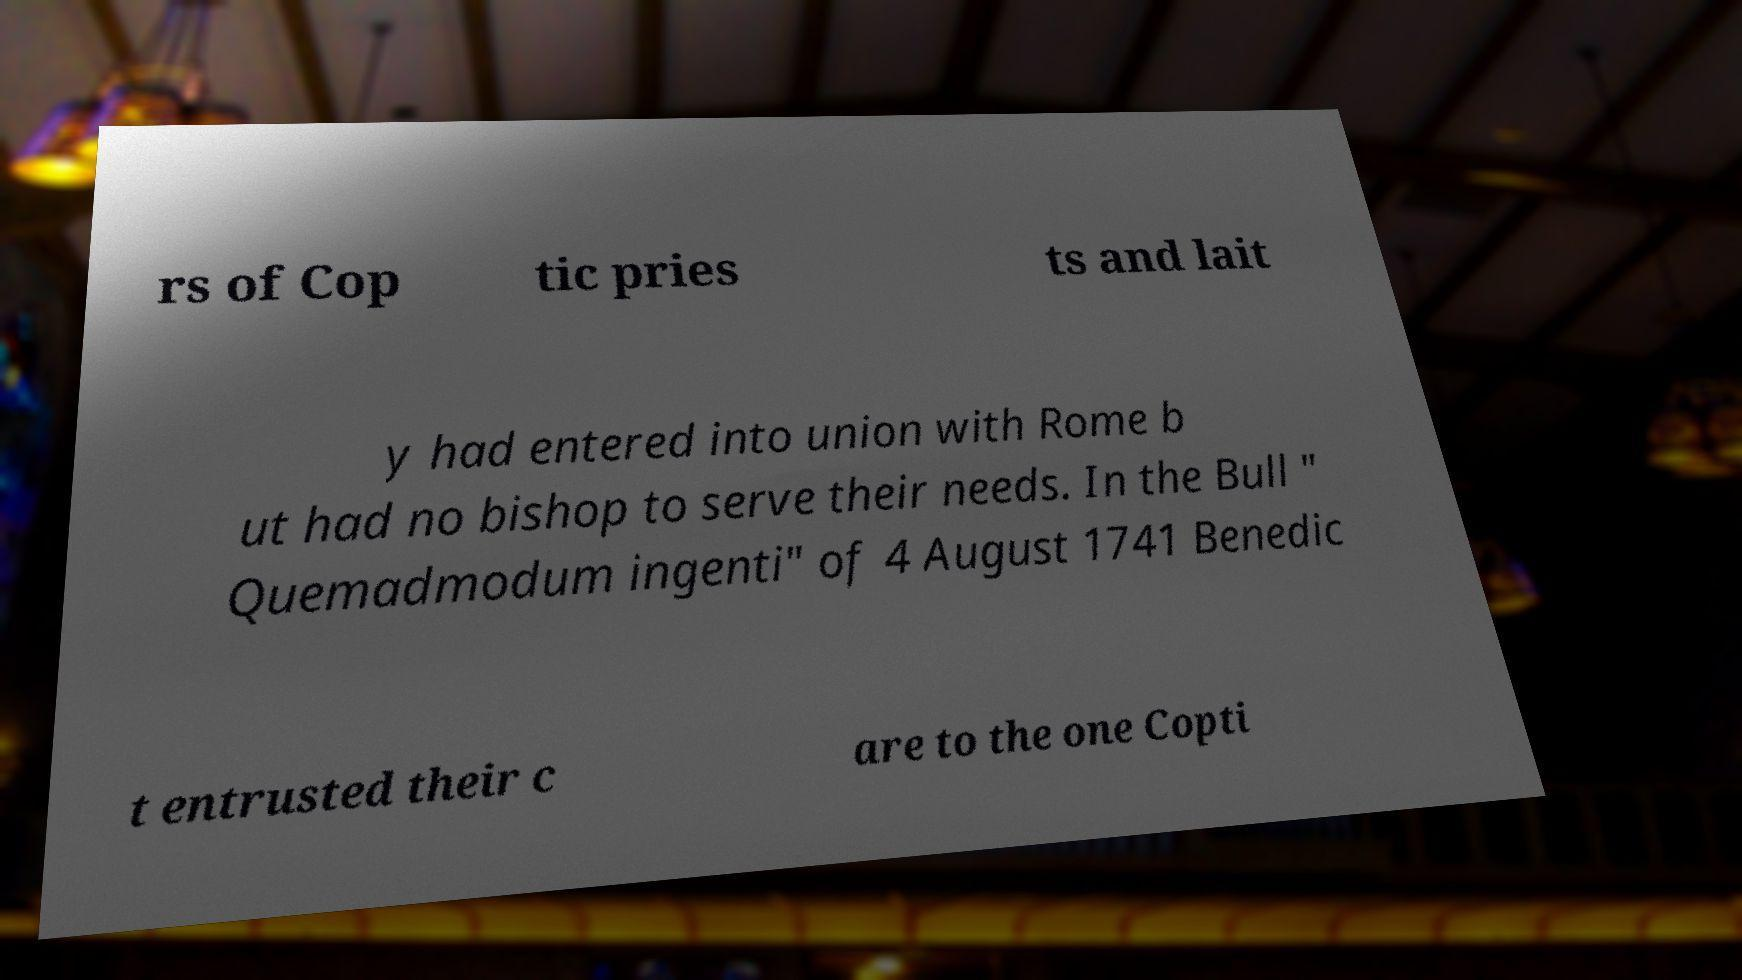Please identify and transcribe the text found in this image. rs of Cop tic pries ts and lait y had entered into union with Rome b ut had no bishop to serve their needs. In the Bull " Quemadmodum ingenti" of 4 August 1741 Benedic t entrusted their c are to the one Copti 